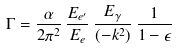<formula> <loc_0><loc_0><loc_500><loc_500>\Gamma = \frac { \alpha } { 2 { \pi } ^ { 2 } } \, \frac { E _ { e ^ { \prime } } } { E _ { e } } \, \frac { E _ { \gamma } } { ( - k ^ { 2 } ) } \, \frac { 1 } { 1 - \epsilon }</formula> 